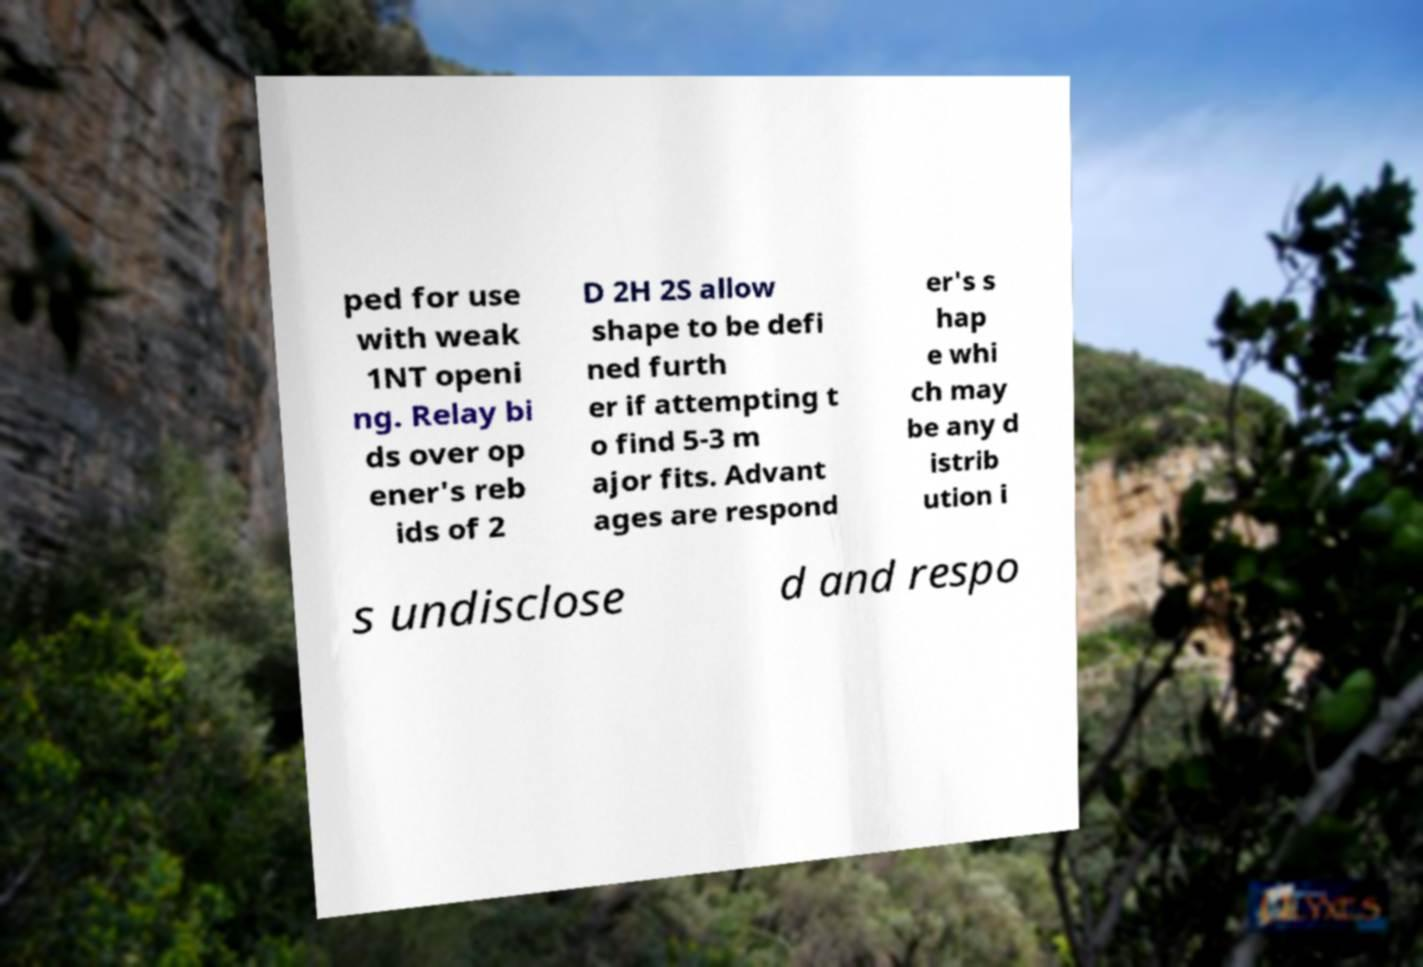Please identify and transcribe the text found in this image. ped for use with weak 1NT openi ng. Relay bi ds over op ener's reb ids of 2 D 2H 2S allow shape to be defi ned furth er if attempting t o find 5-3 m ajor fits. Advant ages are respond er's s hap e whi ch may be any d istrib ution i s undisclose d and respo 